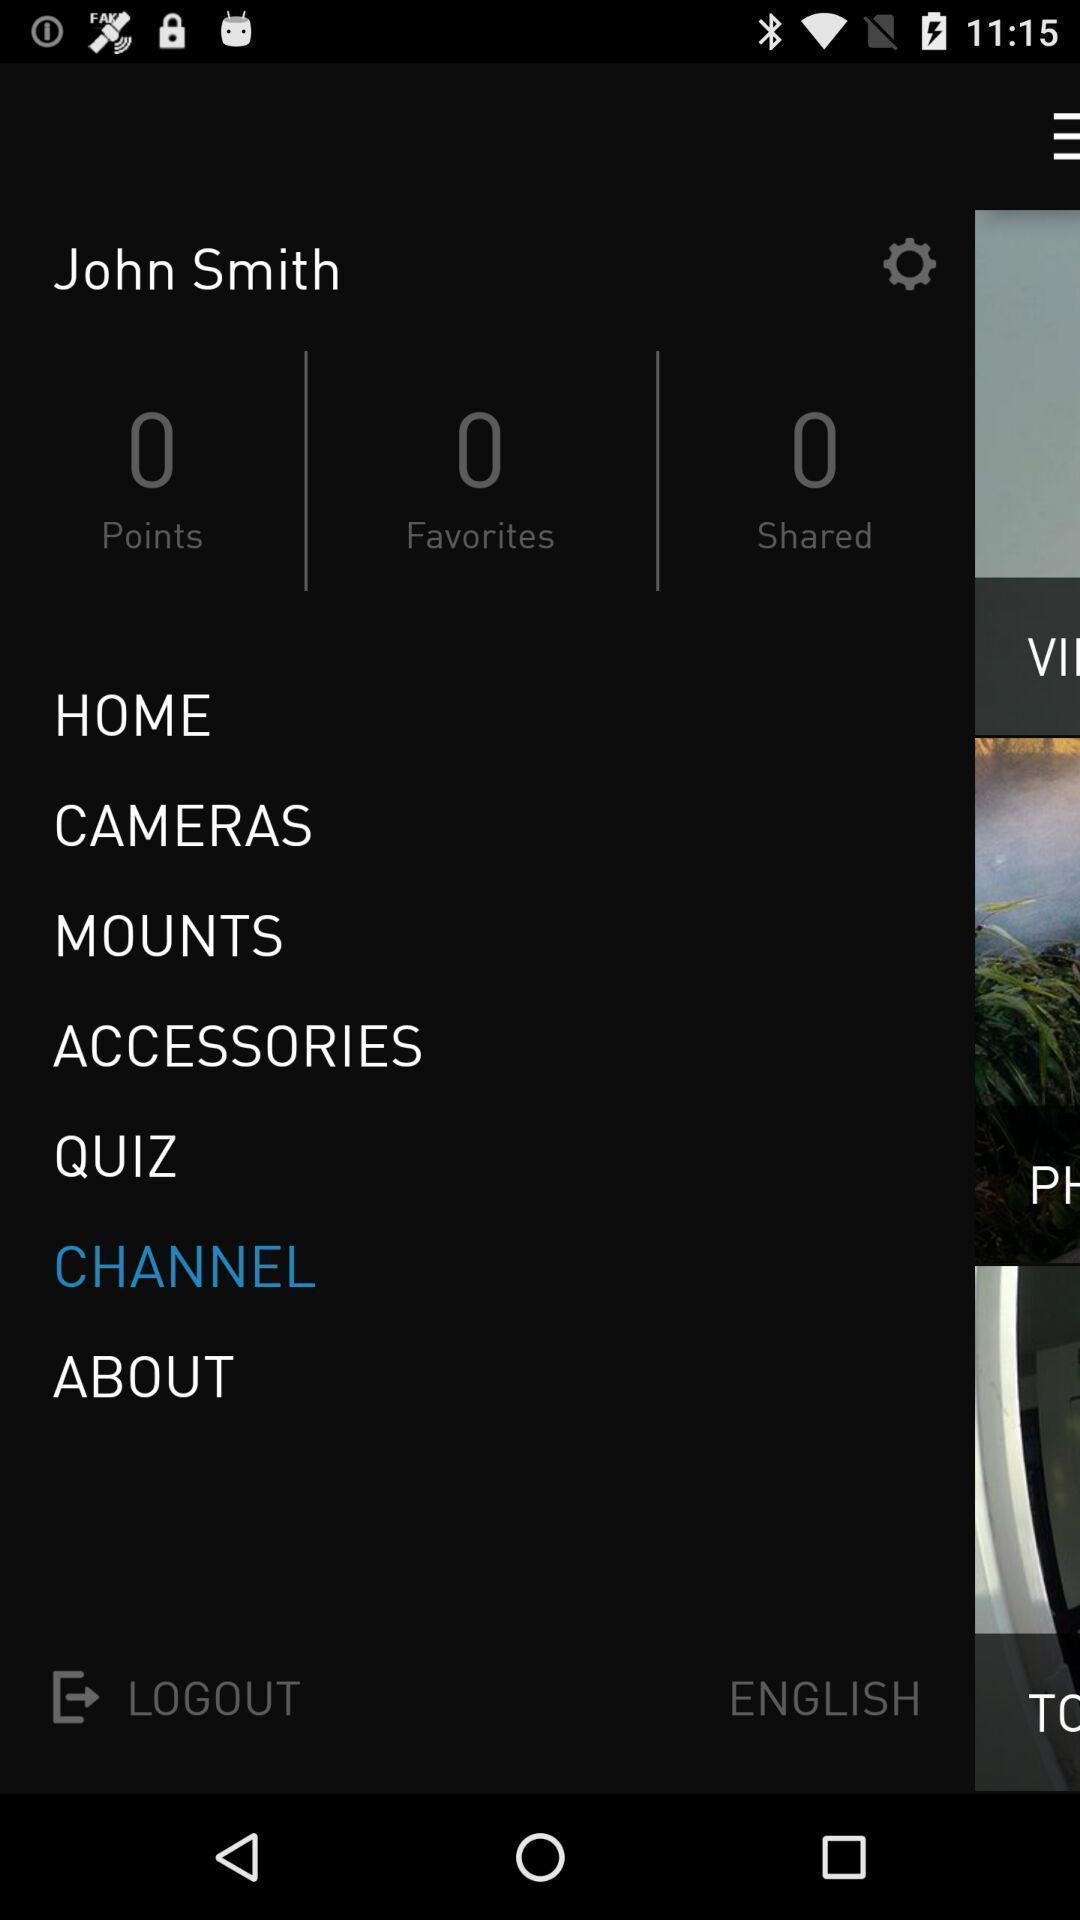Provide a detailed account of this screenshot. Profile page. 